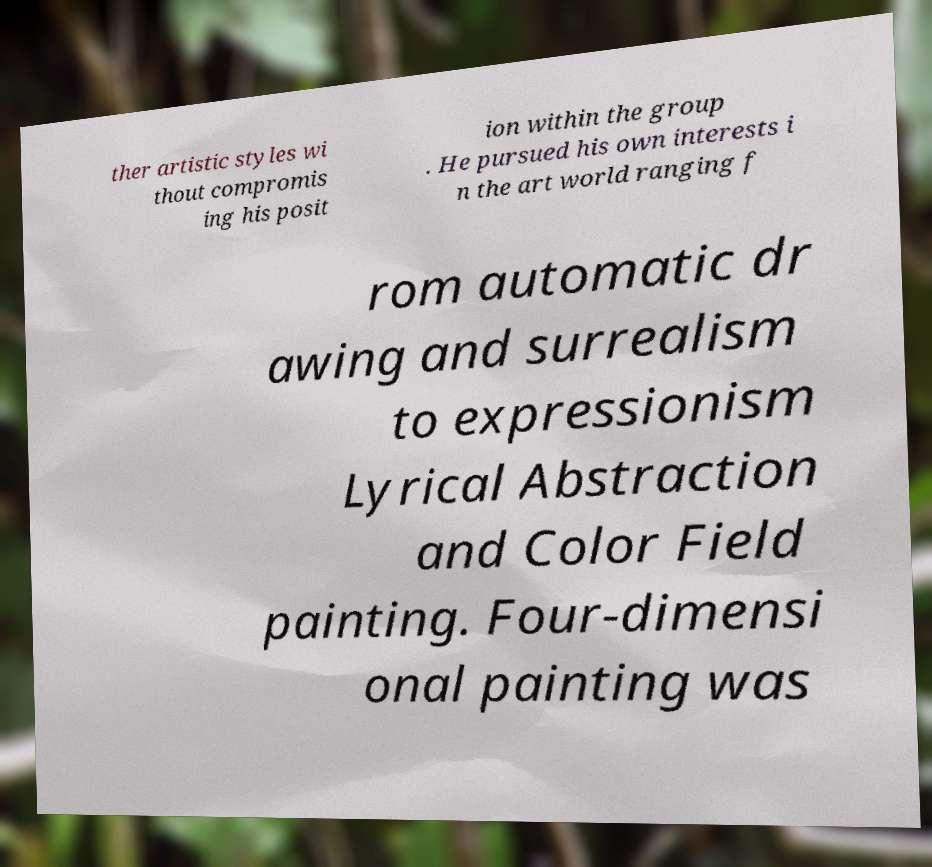There's text embedded in this image that I need extracted. Can you transcribe it verbatim? ther artistic styles wi thout compromis ing his posit ion within the group . He pursued his own interests i n the art world ranging f rom automatic dr awing and surrealism to expressionism Lyrical Abstraction and Color Field painting. Four-dimensi onal painting was 